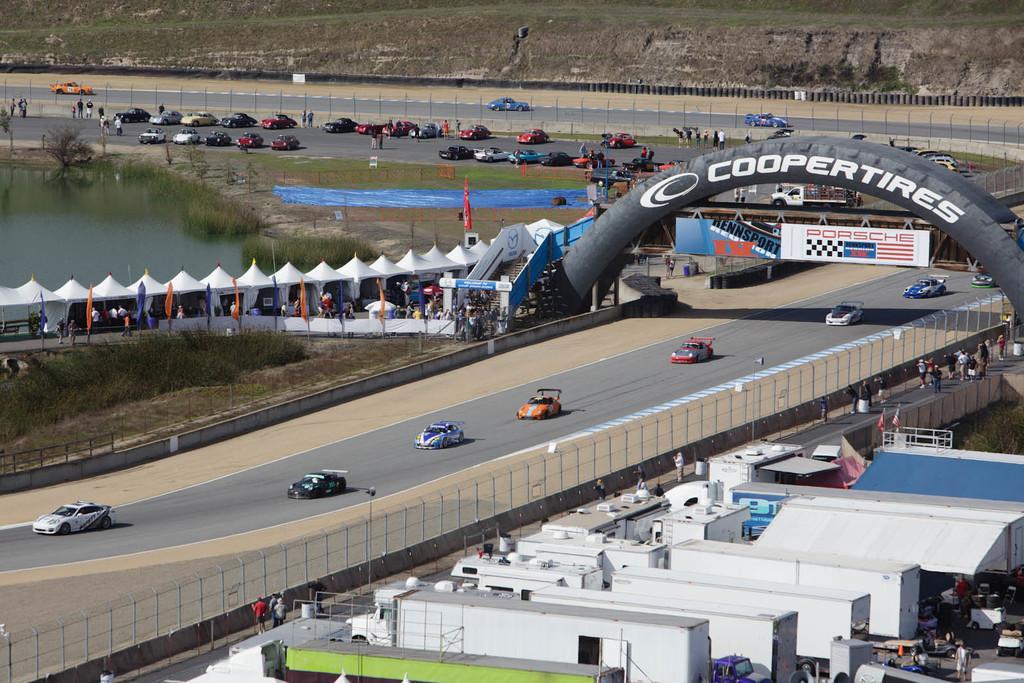Describe this image in one or two sentences. At the bottom of the picture, we see the buildings in white, green and blue color. Beside that, we see the people are standing and we see the trolleys. In the middle, we see the fence and the street lights. Beside that, we see the people are standing and we see the cars moving on the road. On the right side, we see an arch. Behind that, we see a board in white and blue color with some text written on it. On the left side, we see the trees, grass and the flags in orange and blue color. Beside that, we see the people are standing under the white tents. Beside them, we see the staircase. Behind them, we see the water in the pond. In the background, we see the poles and the cars parked on the road. 